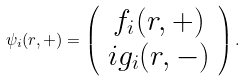<formula> <loc_0><loc_0><loc_500><loc_500>\psi _ { i } ( r , + ) = \left ( \begin{array} { c } f _ { i } ( r , + ) \\ i g _ { i } ( r , - ) \end{array} \right ) .</formula> 